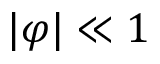<formula> <loc_0><loc_0><loc_500><loc_500>| \varphi | \ll 1</formula> 